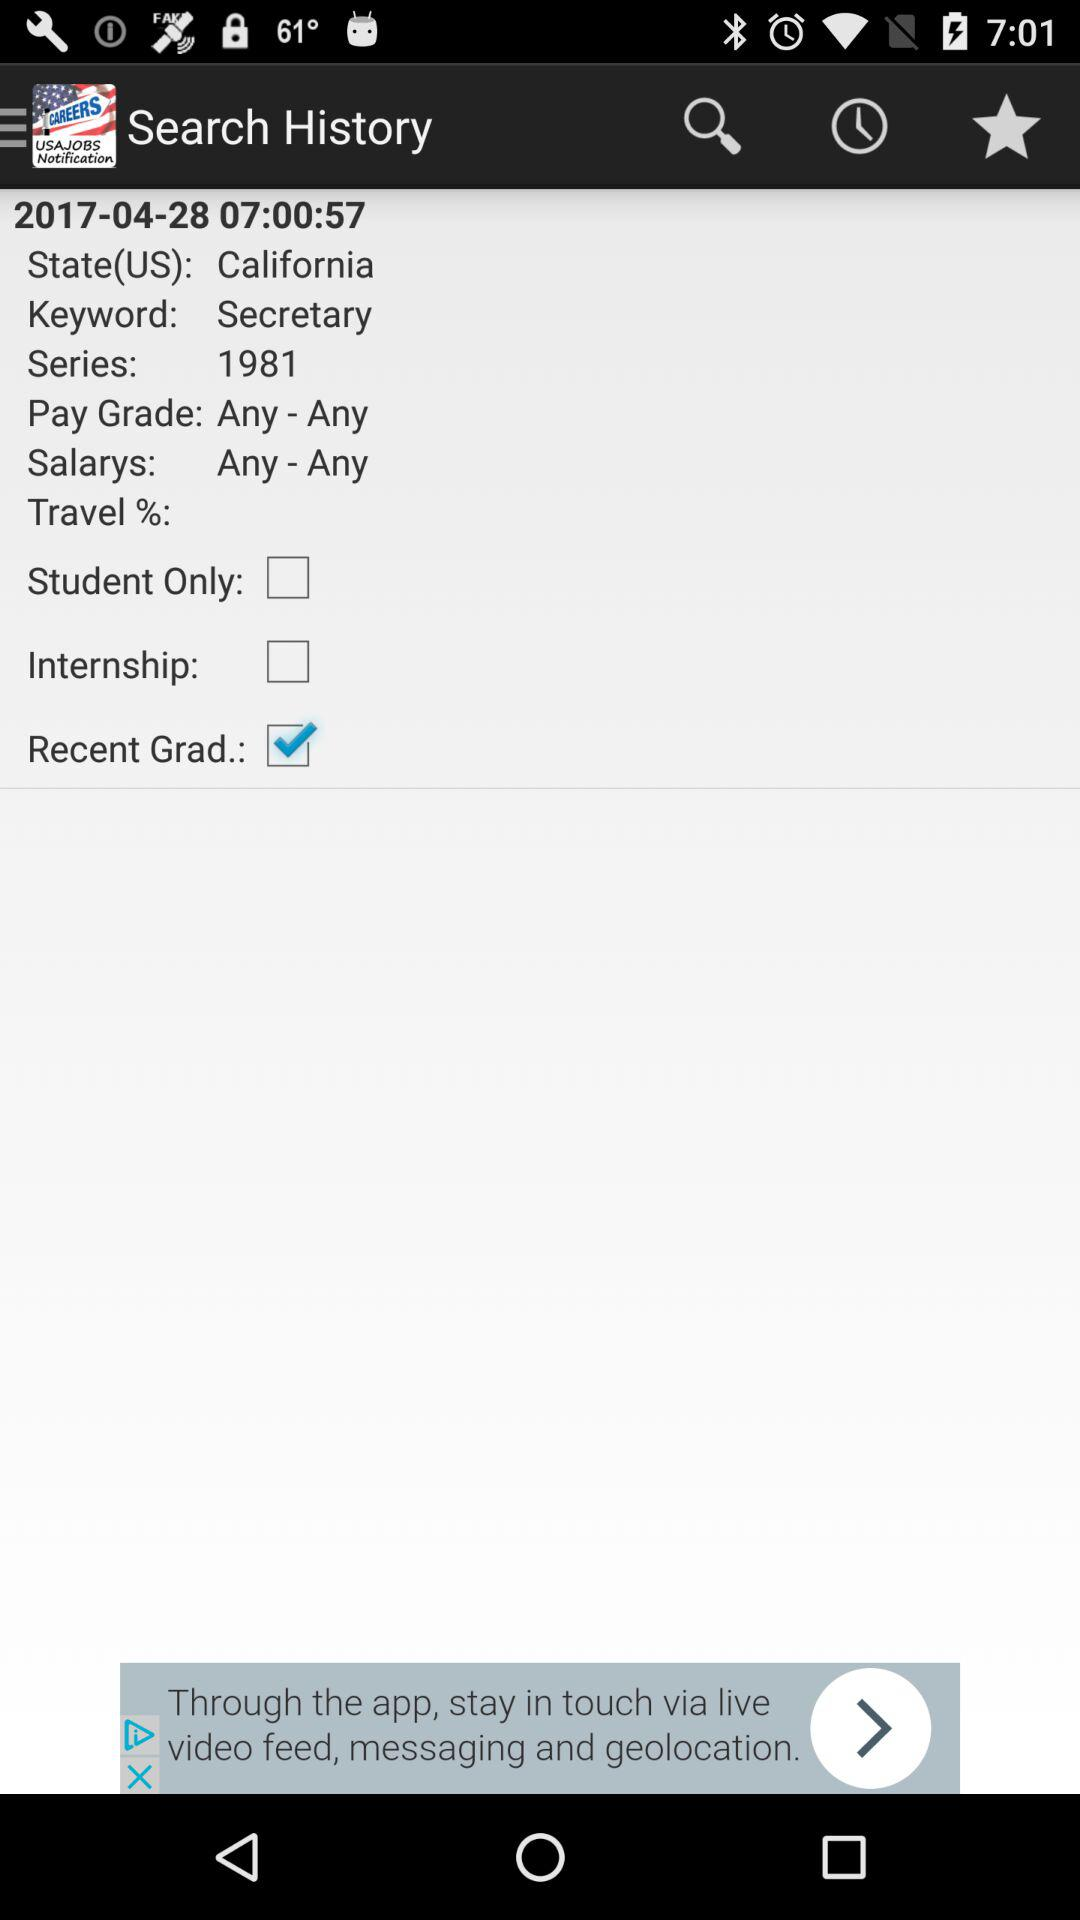What's the keyword? The keyword is "Secretary". 